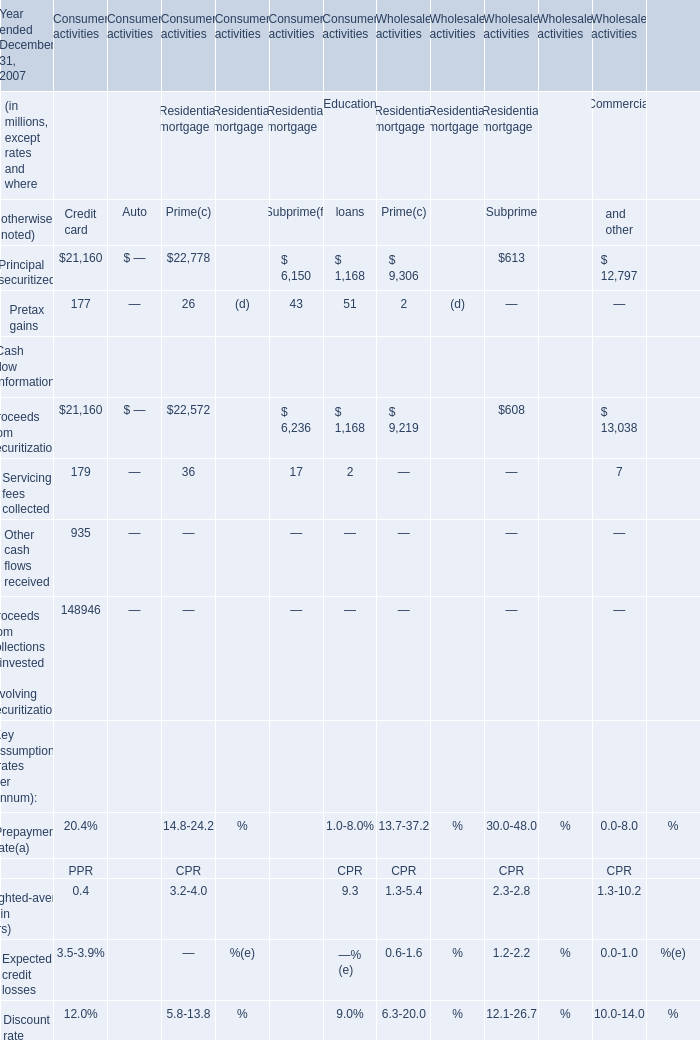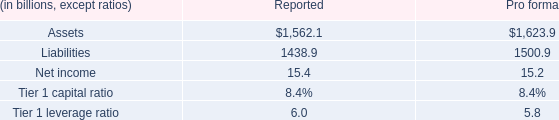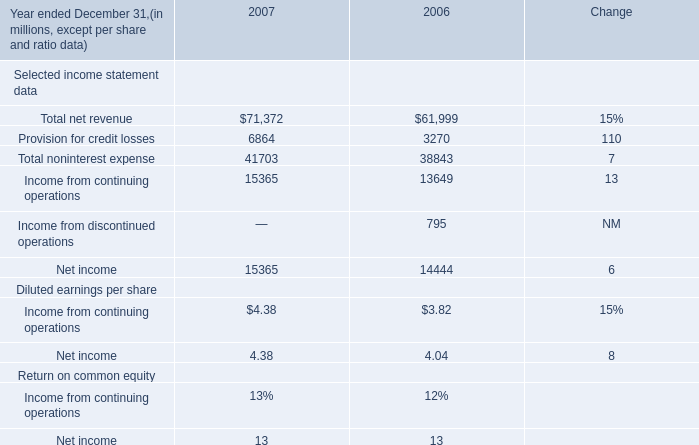what's the total amount of Income from continuing operations of 2006, and Assets of Pro forma ? 
Computations: (13649.0 + 1623.9)
Answer: 15272.9. 